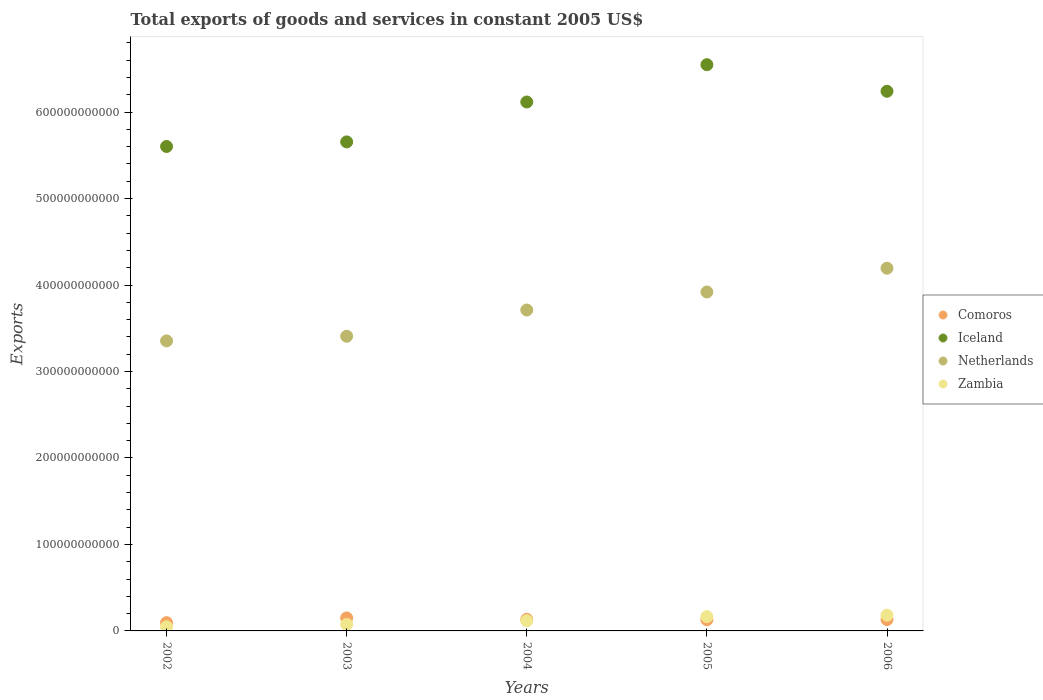How many different coloured dotlines are there?
Make the answer very short. 4. What is the total exports of goods and services in Zambia in 2005?
Provide a short and direct response. 1.65e+1. Across all years, what is the maximum total exports of goods and services in Comoros?
Offer a terse response. 1.50e+1. Across all years, what is the minimum total exports of goods and services in Comoros?
Ensure brevity in your answer.  9.56e+09. In which year was the total exports of goods and services in Iceland maximum?
Offer a terse response. 2005. What is the total total exports of goods and services in Iceland in the graph?
Give a very brief answer. 3.02e+12. What is the difference between the total exports of goods and services in Comoros in 2003 and that in 2006?
Your response must be concise. 1.88e+09. What is the difference between the total exports of goods and services in Zambia in 2006 and the total exports of goods and services in Netherlands in 2005?
Your answer should be compact. -3.74e+11. What is the average total exports of goods and services in Netherlands per year?
Provide a short and direct response. 3.72e+11. In the year 2006, what is the difference between the total exports of goods and services in Netherlands and total exports of goods and services in Zambia?
Offer a terse response. 4.01e+11. In how many years, is the total exports of goods and services in Zambia greater than 80000000000 US$?
Your response must be concise. 0. What is the ratio of the total exports of goods and services in Comoros in 2004 to that in 2005?
Provide a succinct answer. 1.04. Is the total exports of goods and services in Iceland in 2002 less than that in 2006?
Provide a short and direct response. Yes. Is the difference between the total exports of goods and services in Netherlands in 2004 and 2006 greater than the difference between the total exports of goods and services in Zambia in 2004 and 2006?
Your response must be concise. No. What is the difference between the highest and the second highest total exports of goods and services in Iceland?
Offer a very short reply. 3.08e+1. What is the difference between the highest and the lowest total exports of goods and services in Zambia?
Offer a terse response. 1.35e+1. Is the sum of the total exports of goods and services in Zambia in 2005 and 2006 greater than the maximum total exports of goods and services in Netherlands across all years?
Provide a short and direct response. No. Is it the case that in every year, the sum of the total exports of goods and services in Iceland and total exports of goods and services in Netherlands  is greater than the total exports of goods and services in Zambia?
Offer a terse response. Yes. Is the total exports of goods and services in Comoros strictly less than the total exports of goods and services in Zambia over the years?
Offer a terse response. No. How many years are there in the graph?
Give a very brief answer. 5. What is the difference between two consecutive major ticks on the Y-axis?
Ensure brevity in your answer.  1.00e+11. How many legend labels are there?
Make the answer very short. 4. How are the legend labels stacked?
Ensure brevity in your answer.  Vertical. What is the title of the graph?
Give a very brief answer. Total exports of goods and services in constant 2005 US$. What is the label or title of the X-axis?
Ensure brevity in your answer.  Years. What is the label or title of the Y-axis?
Make the answer very short. Exports. What is the Exports in Comoros in 2002?
Offer a very short reply. 9.56e+09. What is the Exports of Iceland in 2002?
Offer a very short reply. 5.60e+11. What is the Exports in Netherlands in 2002?
Provide a short and direct response. 3.35e+11. What is the Exports in Zambia in 2002?
Give a very brief answer. 4.76e+09. What is the Exports in Comoros in 2003?
Ensure brevity in your answer.  1.50e+1. What is the Exports in Iceland in 2003?
Offer a very short reply. 5.66e+11. What is the Exports of Netherlands in 2003?
Give a very brief answer. 3.41e+11. What is the Exports of Zambia in 2003?
Your response must be concise. 7.51e+09. What is the Exports of Comoros in 2004?
Provide a short and direct response. 1.34e+1. What is the Exports of Iceland in 2004?
Ensure brevity in your answer.  6.12e+11. What is the Exports of Netherlands in 2004?
Keep it short and to the point. 3.71e+11. What is the Exports in Zambia in 2004?
Your response must be concise. 1.18e+1. What is the Exports of Comoros in 2005?
Give a very brief answer. 1.29e+1. What is the Exports in Iceland in 2005?
Your response must be concise. 6.55e+11. What is the Exports in Netherlands in 2005?
Your response must be concise. 3.92e+11. What is the Exports in Zambia in 2005?
Your answer should be very brief. 1.65e+1. What is the Exports in Comoros in 2006?
Provide a short and direct response. 1.31e+1. What is the Exports of Iceland in 2006?
Provide a short and direct response. 6.24e+11. What is the Exports in Netherlands in 2006?
Make the answer very short. 4.19e+11. What is the Exports in Zambia in 2006?
Your answer should be very brief. 1.82e+1. Across all years, what is the maximum Exports of Comoros?
Your answer should be very brief. 1.50e+1. Across all years, what is the maximum Exports of Iceland?
Your response must be concise. 6.55e+11. Across all years, what is the maximum Exports in Netherlands?
Provide a short and direct response. 4.19e+11. Across all years, what is the maximum Exports of Zambia?
Provide a succinct answer. 1.82e+1. Across all years, what is the minimum Exports in Comoros?
Your response must be concise. 9.56e+09. Across all years, what is the minimum Exports in Iceland?
Offer a terse response. 5.60e+11. Across all years, what is the minimum Exports of Netherlands?
Keep it short and to the point. 3.35e+11. Across all years, what is the minimum Exports in Zambia?
Offer a terse response. 4.76e+09. What is the total Exports of Comoros in the graph?
Offer a very short reply. 6.40e+1. What is the total Exports of Iceland in the graph?
Make the answer very short. 3.02e+12. What is the total Exports in Netherlands in the graph?
Make the answer very short. 1.86e+12. What is the total Exports of Zambia in the graph?
Provide a succinct answer. 5.88e+1. What is the difference between the Exports in Comoros in 2002 and that in 2003?
Keep it short and to the point. -5.45e+09. What is the difference between the Exports of Iceland in 2002 and that in 2003?
Ensure brevity in your answer.  -5.29e+09. What is the difference between the Exports in Netherlands in 2002 and that in 2003?
Offer a terse response. -5.38e+09. What is the difference between the Exports of Zambia in 2002 and that in 2003?
Your response must be concise. -2.75e+09. What is the difference between the Exports in Comoros in 2002 and that in 2004?
Make the answer very short. -3.87e+09. What is the difference between the Exports of Iceland in 2002 and that in 2004?
Provide a short and direct response. -5.15e+1. What is the difference between the Exports in Netherlands in 2002 and that in 2004?
Your answer should be compact. -3.57e+1. What is the difference between the Exports in Zambia in 2002 and that in 2004?
Provide a short and direct response. -7.05e+09. What is the difference between the Exports in Comoros in 2002 and that in 2005?
Offer a terse response. -3.35e+09. What is the difference between the Exports in Iceland in 2002 and that in 2005?
Your answer should be very brief. -9.46e+1. What is the difference between the Exports of Netherlands in 2002 and that in 2005?
Ensure brevity in your answer.  -5.66e+1. What is the difference between the Exports of Zambia in 2002 and that in 2005?
Give a very brief answer. -1.17e+1. What is the difference between the Exports in Comoros in 2002 and that in 2006?
Provide a short and direct response. -3.57e+09. What is the difference between the Exports in Iceland in 2002 and that in 2006?
Your response must be concise. -6.38e+1. What is the difference between the Exports in Netherlands in 2002 and that in 2006?
Your answer should be compact. -8.41e+1. What is the difference between the Exports in Zambia in 2002 and that in 2006?
Offer a very short reply. -1.35e+1. What is the difference between the Exports in Comoros in 2003 and that in 2004?
Provide a short and direct response. 1.58e+09. What is the difference between the Exports in Iceland in 2003 and that in 2004?
Offer a very short reply. -4.62e+1. What is the difference between the Exports of Netherlands in 2003 and that in 2004?
Offer a very short reply. -3.03e+1. What is the difference between the Exports in Zambia in 2003 and that in 2004?
Provide a short and direct response. -4.29e+09. What is the difference between the Exports of Comoros in 2003 and that in 2005?
Your answer should be very brief. 2.10e+09. What is the difference between the Exports of Iceland in 2003 and that in 2005?
Make the answer very short. -8.93e+1. What is the difference between the Exports in Netherlands in 2003 and that in 2005?
Provide a succinct answer. -5.12e+1. What is the difference between the Exports of Zambia in 2003 and that in 2005?
Offer a terse response. -8.98e+09. What is the difference between the Exports of Comoros in 2003 and that in 2006?
Offer a terse response. 1.88e+09. What is the difference between the Exports in Iceland in 2003 and that in 2006?
Provide a succinct answer. -5.85e+1. What is the difference between the Exports in Netherlands in 2003 and that in 2006?
Your answer should be very brief. -7.87e+1. What is the difference between the Exports of Zambia in 2003 and that in 2006?
Offer a very short reply. -1.07e+1. What is the difference between the Exports in Comoros in 2004 and that in 2005?
Make the answer very short. 5.22e+08. What is the difference between the Exports in Iceland in 2004 and that in 2005?
Give a very brief answer. -4.31e+1. What is the difference between the Exports of Netherlands in 2004 and that in 2005?
Ensure brevity in your answer.  -2.08e+1. What is the difference between the Exports in Zambia in 2004 and that in 2005?
Ensure brevity in your answer.  -4.69e+09. What is the difference between the Exports of Comoros in 2004 and that in 2006?
Give a very brief answer. 2.98e+08. What is the difference between the Exports of Iceland in 2004 and that in 2006?
Keep it short and to the point. -1.24e+1. What is the difference between the Exports of Netherlands in 2004 and that in 2006?
Offer a very short reply. -4.83e+1. What is the difference between the Exports in Zambia in 2004 and that in 2006?
Your response must be concise. -6.41e+09. What is the difference between the Exports of Comoros in 2005 and that in 2006?
Ensure brevity in your answer.  -2.24e+08. What is the difference between the Exports in Iceland in 2005 and that in 2006?
Offer a very short reply. 3.08e+1. What is the difference between the Exports in Netherlands in 2005 and that in 2006?
Offer a very short reply. -2.75e+1. What is the difference between the Exports of Zambia in 2005 and that in 2006?
Keep it short and to the point. -1.72e+09. What is the difference between the Exports in Comoros in 2002 and the Exports in Iceland in 2003?
Offer a terse response. -5.56e+11. What is the difference between the Exports of Comoros in 2002 and the Exports of Netherlands in 2003?
Make the answer very short. -3.31e+11. What is the difference between the Exports of Comoros in 2002 and the Exports of Zambia in 2003?
Make the answer very short. 2.05e+09. What is the difference between the Exports in Iceland in 2002 and the Exports in Netherlands in 2003?
Your response must be concise. 2.19e+11. What is the difference between the Exports of Iceland in 2002 and the Exports of Zambia in 2003?
Offer a terse response. 5.53e+11. What is the difference between the Exports of Netherlands in 2002 and the Exports of Zambia in 2003?
Your response must be concise. 3.28e+11. What is the difference between the Exports of Comoros in 2002 and the Exports of Iceland in 2004?
Offer a very short reply. -6.02e+11. What is the difference between the Exports of Comoros in 2002 and the Exports of Netherlands in 2004?
Give a very brief answer. -3.62e+11. What is the difference between the Exports of Comoros in 2002 and the Exports of Zambia in 2004?
Your response must be concise. -2.24e+09. What is the difference between the Exports in Iceland in 2002 and the Exports in Netherlands in 2004?
Your answer should be compact. 1.89e+11. What is the difference between the Exports of Iceland in 2002 and the Exports of Zambia in 2004?
Provide a short and direct response. 5.48e+11. What is the difference between the Exports in Netherlands in 2002 and the Exports in Zambia in 2004?
Your answer should be very brief. 3.24e+11. What is the difference between the Exports in Comoros in 2002 and the Exports in Iceland in 2005?
Ensure brevity in your answer.  -6.45e+11. What is the difference between the Exports of Comoros in 2002 and the Exports of Netherlands in 2005?
Make the answer very short. -3.82e+11. What is the difference between the Exports in Comoros in 2002 and the Exports in Zambia in 2005?
Provide a short and direct response. -6.93e+09. What is the difference between the Exports of Iceland in 2002 and the Exports of Netherlands in 2005?
Provide a succinct answer. 1.68e+11. What is the difference between the Exports in Iceland in 2002 and the Exports in Zambia in 2005?
Give a very brief answer. 5.44e+11. What is the difference between the Exports of Netherlands in 2002 and the Exports of Zambia in 2005?
Keep it short and to the point. 3.19e+11. What is the difference between the Exports of Comoros in 2002 and the Exports of Iceland in 2006?
Your answer should be very brief. -6.15e+11. What is the difference between the Exports of Comoros in 2002 and the Exports of Netherlands in 2006?
Provide a succinct answer. -4.10e+11. What is the difference between the Exports of Comoros in 2002 and the Exports of Zambia in 2006?
Your answer should be compact. -8.65e+09. What is the difference between the Exports of Iceland in 2002 and the Exports of Netherlands in 2006?
Make the answer very short. 1.41e+11. What is the difference between the Exports of Iceland in 2002 and the Exports of Zambia in 2006?
Offer a very short reply. 5.42e+11. What is the difference between the Exports of Netherlands in 2002 and the Exports of Zambia in 2006?
Provide a short and direct response. 3.17e+11. What is the difference between the Exports of Comoros in 2003 and the Exports of Iceland in 2004?
Make the answer very short. -5.97e+11. What is the difference between the Exports of Comoros in 2003 and the Exports of Netherlands in 2004?
Provide a succinct answer. -3.56e+11. What is the difference between the Exports in Comoros in 2003 and the Exports in Zambia in 2004?
Ensure brevity in your answer.  3.21e+09. What is the difference between the Exports of Iceland in 2003 and the Exports of Netherlands in 2004?
Keep it short and to the point. 1.94e+11. What is the difference between the Exports of Iceland in 2003 and the Exports of Zambia in 2004?
Offer a terse response. 5.54e+11. What is the difference between the Exports of Netherlands in 2003 and the Exports of Zambia in 2004?
Your answer should be compact. 3.29e+11. What is the difference between the Exports in Comoros in 2003 and the Exports in Iceland in 2005?
Ensure brevity in your answer.  -6.40e+11. What is the difference between the Exports in Comoros in 2003 and the Exports in Netherlands in 2005?
Your answer should be very brief. -3.77e+11. What is the difference between the Exports of Comoros in 2003 and the Exports of Zambia in 2005?
Give a very brief answer. -1.48e+09. What is the difference between the Exports of Iceland in 2003 and the Exports of Netherlands in 2005?
Offer a very short reply. 1.74e+11. What is the difference between the Exports of Iceland in 2003 and the Exports of Zambia in 2005?
Provide a short and direct response. 5.49e+11. What is the difference between the Exports in Netherlands in 2003 and the Exports in Zambia in 2005?
Ensure brevity in your answer.  3.24e+11. What is the difference between the Exports in Comoros in 2003 and the Exports in Iceland in 2006?
Provide a succinct answer. -6.09e+11. What is the difference between the Exports in Comoros in 2003 and the Exports in Netherlands in 2006?
Offer a terse response. -4.04e+11. What is the difference between the Exports of Comoros in 2003 and the Exports of Zambia in 2006?
Provide a succinct answer. -3.20e+09. What is the difference between the Exports in Iceland in 2003 and the Exports in Netherlands in 2006?
Make the answer very short. 1.46e+11. What is the difference between the Exports in Iceland in 2003 and the Exports in Zambia in 2006?
Offer a very short reply. 5.47e+11. What is the difference between the Exports in Netherlands in 2003 and the Exports in Zambia in 2006?
Offer a very short reply. 3.23e+11. What is the difference between the Exports in Comoros in 2004 and the Exports in Iceland in 2005?
Your response must be concise. -6.41e+11. What is the difference between the Exports in Comoros in 2004 and the Exports in Netherlands in 2005?
Provide a succinct answer. -3.79e+11. What is the difference between the Exports in Comoros in 2004 and the Exports in Zambia in 2005?
Offer a terse response. -3.06e+09. What is the difference between the Exports in Iceland in 2004 and the Exports in Netherlands in 2005?
Give a very brief answer. 2.20e+11. What is the difference between the Exports of Iceland in 2004 and the Exports of Zambia in 2005?
Your answer should be compact. 5.95e+11. What is the difference between the Exports in Netherlands in 2004 and the Exports in Zambia in 2005?
Give a very brief answer. 3.55e+11. What is the difference between the Exports in Comoros in 2004 and the Exports in Iceland in 2006?
Give a very brief answer. -6.11e+11. What is the difference between the Exports of Comoros in 2004 and the Exports of Netherlands in 2006?
Keep it short and to the point. -4.06e+11. What is the difference between the Exports in Comoros in 2004 and the Exports in Zambia in 2006?
Offer a very short reply. -4.78e+09. What is the difference between the Exports of Iceland in 2004 and the Exports of Netherlands in 2006?
Make the answer very short. 1.92e+11. What is the difference between the Exports of Iceland in 2004 and the Exports of Zambia in 2006?
Provide a short and direct response. 5.94e+11. What is the difference between the Exports in Netherlands in 2004 and the Exports in Zambia in 2006?
Give a very brief answer. 3.53e+11. What is the difference between the Exports of Comoros in 2005 and the Exports of Iceland in 2006?
Provide a succinct answer. -6.11e+11. What is the difference between the Exports in Comoros in 2005 and the Exports in Netherlands in 2006?
Offer a very short reply. -4.07e+11. What is the difference between the Exports in Comoros in 2005 and the Exports in Zambia in 2006?
Make the answer very short. -5.30e+09. What is the difference between the Exports in Iceland in 2005 and the Exports in Netherlands in 2006?
Ensure brevity in your answer.  2.35e+11. What is the difference between the Exports of Iceland in 2005 and the Exports of Zambia in 2006?
Make the answer very short. 6.37e+11. What is the difference between the Exports in Netherlands in 2005 and the Exports in Zambia in 2006?
Provide a succinct answer. 3.74e+11. What is the average Exports of Comoros per year?
Keep it short and to the point. 1.28e+1. What is the average Exports of Iceland per year?
Offer a terse response. 6.03e+11. What is the average Exports in Netherlands per year?
Provide a short and direct response. 3.72e+11. What is the average Exports of Zambia per year?
Your response must be concise. 1.18e+1. In the year 2002, what is the difference between the Exports of Comoros and Exports of Iceland?
Provide a short and direct response. -5.51e+11. In the year 2002, what is the difference between the Exports in Comoros and Exports in Netherlands?
Keep it short and to the point. -3.26e+11. In the year 2002, what is the difference between the Exports of Comoros and Exports of Zambia?
Offer a very short reply. 4.81e+09. In the year 2002, what is the difference between the Exports of Iceland and Exports of Netherlands?
Give a very brief answer. 2.25e+11. In the year 2002, what is the difference between the Exports of Iceland and Exports of Zambia?
Offer a very short reply. 5.56e+11. In the year 2002, what is the difference between the Exports in Netherlands and Exports in Zambia?
Offer a terse response. 3.31e+11. In the year 2003, what is the difference between the Exports of Comoros and Exports of Iceland?
Give a very brief answer. -5.51e+11. In the year 2003, what is the difference between the Exports in Comoros and Exports in Netherlands?
Ensure brevity in your answer.  -3.26e+11. In the year 2003, what is the difference between the Exports of Comoros and Exports of Zambia?
Provide a short and direct response. 7.50e+09. In the year 2003, what is the difference between the Exports of Iceland and Exports of Netherlands?
Your answer should be very brief. 2.25e+11. In the year 2003, what is the difference between the Exports in Iceland and Exports in Zambia?
Make the answer very short. 5.58e+11. In the year 2003, what is the difference between the Exports of Netherlands and Exports of Zambia?
Ensure brevity in your answer.  3.33e+11. In the year 2004, what is the difference between the Exports of Comoros and Exports of Iceland?
Make the answer very short. -5.98e+11. In the year 2004, what is the difference between the Exports in Comoros and Exports in Netherlands?
Ensure brevity in your answer.  -3.58e+11. In the year 2004, what is the difference between the Exports in Comoros and Exports in Zambia?
Give a very brief answer. 1.63e+09. In the year 2004, what is the difference between the Exports of Iceland and Exports of Netherlands?
Give a very brief answer. 2.41e+11. In the year 2004, what is the difference between the Exports of Iceland and Exports of Zambia?
Your answer should be very brief. 6.00e+11. In the year 2004, what is the difference between the Exports of Netherlands and Exports of Zambia?
Keep it short and to the point. 3.59e+11. In the year 2005, what is the difference between the Exports of Comoros and Exports of Iceland?
Your response must be concise. -6.42e+11. In the year 2005, what is the difference between the Exports in Comoros and Exports in Netherlands?
Ensure brevity in your answer.  -3.79e+11. In the year 2005, what is the difference between the Exports of Comoros and Exports of Zambia?
Provide a succinct answer. -3.58e+09. In the year 2005, what is the difference between the Exports of Iceland and Exports of Netherlands?
Keep it short and to the point. 2.63e+11. In the year 2005, what is the difference between the Exports of Iceland and Exports of Zambia?
Provide a short and direct response. 6.38e+11. In the year 2005, what is the difference between the Exports of Netherlands and Exports of Zambia?
Ensure brevity in your answer.  3.75e+11. In the year 2006, what is the difference between the Exports in Comoros and Exports in Iceland?
Provide a short and direct response. -6.11e+11. In the year 2006, what is the difference between the Exports of Comoros and Exports of Netherlands?
Your answer should be compact. -4.06e+11. In the year 2006, what is the difference between the Exports in Comoros and Exports in Zambia?
Your answer should be compact. -5.08e+09. In the year 2006, what is the difference between the Exports in Iceland and Exports in Netherlands?
Keep it short and to the point. 2.05e+11. In the year 2006, what is the difference between the Exports of Iceland and Exports of Zambia?
Offer a terse response. 6.06e+11. In the year 2006, what is the difference between the Exports of Netherlands and Exports of Zambia?
Keep it short and to the point. 4.01e+11. What is the ratio of the Exports of Comoros in 2002 to that in 2003?
Your response must be concise. 0.64. What is the ratio of the Exports in Iceland in 2002 to that in 2003?
Provide a succinct answer. 0.99. What is the ratio of the Exports of Netherlands in 2002 to that in 2003?
Give a very brief answer. 0.98. What is the ratio of the Exports in Zambia in 2002 to that in 2003?
Your answer should be compact. 0.63. What is the ratio of the Exports in Comoros in 2002 to that in 2004?
Your answer should be compact. 0.71. What is the ratio of the Exports of Iceland in 2002 to that in 2004?
Provide a succinct answer. 0.92. What is the ratio of the Exports of Netherlands in 2002 to that in 2004?
Provide a succinct answer. 0.9. What is the ratio of the Exports of Zambia in 2002 to that in 2004?
Give a very brief answer. 0.4. What is the ratio of the Exports in Comoros in 2002 to that in 2005?
Give a very brief answer. 0.74. What is the ratio of the Exports in Iceland in 2002 to that in 2005?
Your response must be concise. 0.86. What is the ratio of the Exports of Netherlands in 2002 to that in 2005?
Provide a short and direct response. 0.86. What is the ratio of the Exports in Zambia in 2002 to that in 2005?
Ensure brevity in your answer.  0.29. What is the ratio of the Exports of Comoros in 2002 to that in 2006?
Offer a terse response. 0.73. What is the ratio of the Exports in Iceland in 2002 to that in 2006?
Offer a terse response. 0.9. What is the ratio of the Exports of Netherlands in 2002 to that in 2006?
Your answer should be very brief. 0.8. What is the ratio of the Exports in Zambia in 2002 to that in 2006?
Give a very brief answer. 0.26. What is the ratio of the Exports in Comoros in 2003 to that in 2004?
Your answer should be very brief. 1.12. What is the ratio of the Exports of Iceland in 2003 to that in 2004?
Give a very brief answer. 0.92. What is the ratio of the Exports of Netherlands in 2003 to that in 2004?
Your response must be concise. 0.92. What is the ratio of the Exports of Zambia in 2003 to that in 2004?
Offer a very short reply. 0.64. What is the ratio of the Exports in Comoros in 2003 to that in 2005?
Keep it short and to the point. 1.16. What is the ratio of the Exports in Iceland in 2003 to that in 2005?
Offer a very short reply. 0.86. What is the ratio of the Exports in Netherlands in 2003 to that in 2005?
Your answer should be very brief. 0.87. What is the ratio of the Exports in Zambia in 2003 to that in 2005?
Your response must be concise. 0.46. What is the ratio of the Exports of Comoros in 2003 to that in 2006?
Your answer should be compact. 1.14. What is the ratio of the Exports in Iceland in 2003 to that in 2006?
Give a very brief answer. 0.91. What is the ratio of the Exports in Netherlands in 2003 to that in 2006?
Keep it short and to the point. 0.81. What is the ratio of the Exports in Zambia in 2003 to that in 2006?
Ensure brevity in your answer.  0.41. What is the ratio of the Exports of Comoros in 2004 to that in 2005?
Make the answer very short. 1.04. What is the ratio of the Exports of Iceland in 2004 to that in 2005?
Ensure brevity in your answer.  0.93. What is the ratio of the Exports in Netherlands in 2004 to that in 2005?
Offer a very short reply. 0.95. What is the ratio of the Exports in Zambia in 2004 to that in 2005?
Your answer should be very brief. 0.72. What is the ratio of the Exports in Comoros in 2004 to that in 2006?
Provide a succinct answer. 1.02. What is the ratio of the Exports of Iceland in 2004 to that in 2006?
Offer a very short reply. 0.98. What is the ratio of the Exports of Netherlands in 2004 to that in 2006?
Your answer should be very brief. 0.88. What is the ratio of the Exports in Zambia in 2004 to that in 2006?
Offer a terse response. 0.65. What is the ratio of the Exports of Comoros in 2005 to that in 2006?
Provide a short and direct response. 0.98. What is the ratio of the Exports in Iceland in 2005 to that in 2006?
Provide a succinct answer. 1.05. What is the ratio of the Exports in Netherlands in 2005 to that in 2006?
Provide a succinct answer. 0.93. What is the ratio of the Exports of Zambia in 2005 to that in 2006?
Provide a succinct answer. 0.91. What is the difference between the highest and the second highest Exports in Comoros?
Provide a short and direct response. 1.58e+09. What is the difference between the highest and the second highest Exports in Iceland?
Your response must be concise. 3.08e+1. What is the difference between the highest and the second highest Exports in Netherlands?
Offer a terse response. 2.75e+1. What is the difference between the highest and the second highest Exports in Zambia?
Your response must be concise. 1.72e+09. What is the difference between the highest and the lowest Exports of Comoros?
Provide a succinct answer. 5.45e+09. What is the difference between the highest and the lowest Exports in Iceland?
Your response must be concise. 9.46e+1. What is the difference between the highest and the lowest Exports of Netherlands?
Provide a succinct answer. 8.41e+1. What is the difference between the highest and the lowest Exports of Zambia?
Your answer should be compact. 1.35e+1. 